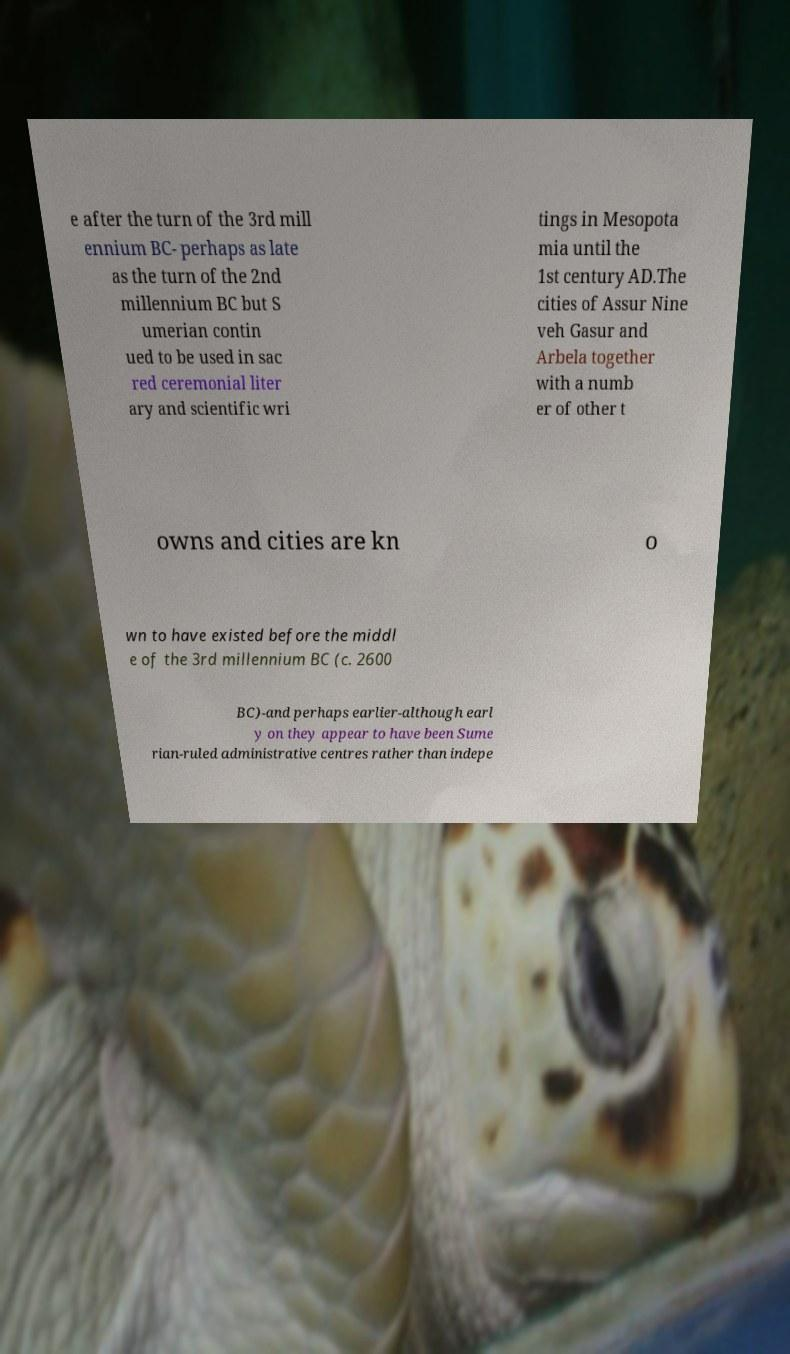Could you assist in decoding the text presented in this image and type it out clearly? e after the turn of the 3rd mill ennium BC- perhaps as late as the turn of the 2nd millennium BC but S umerian contin ued to be used in sac red ceremonial liter ary and scientific wri tings in Mesopota mia until the 1st century AD.The cities of Assur Nine veh Gasur and Arbela together with a numb er of other t owns and cities are kn o wn to have existed before the middl e of the 3rd millennium BC (c. 2600 BC)-and perhaps earlier-although earl y on they appear to have been Sume rian-ruled administrative centres rather than indepe 